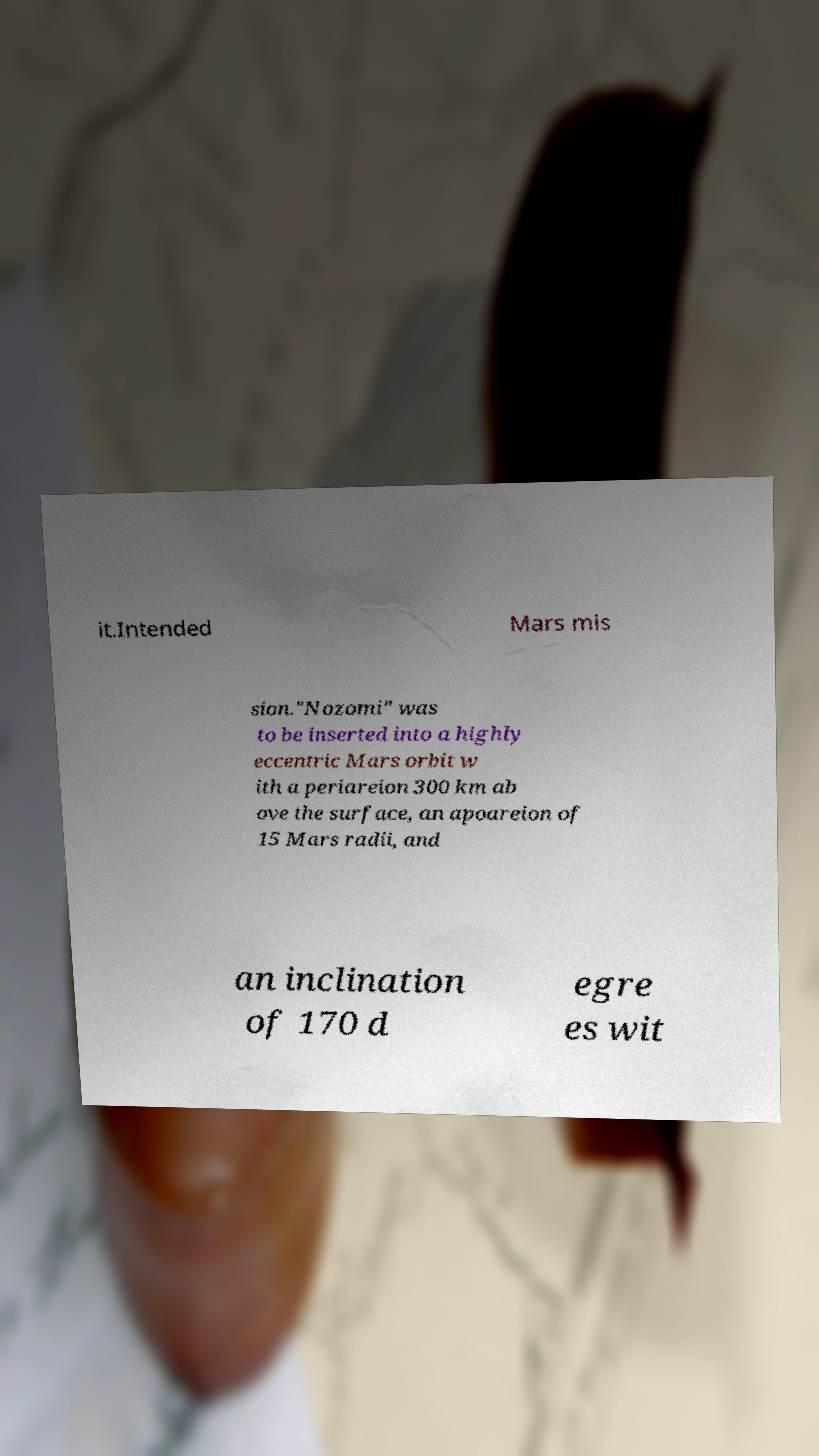Please read and relay the text visible in this image. What does it say? it.Intended Mars mis sion."Nozomi" was to be inserted into a highly eccentric Mars orbit w ith a periareion 300 km ab ove the surface, an apoareion of 15 Mars radii, and an inclination of 170 d egre es wit 